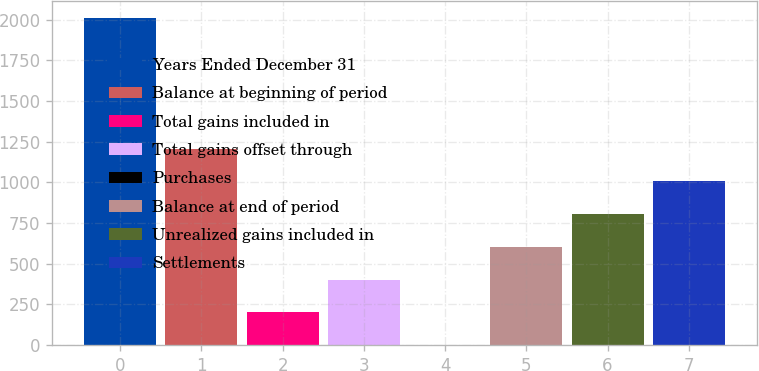<chart> <loc_0><loc_0><loc_500><loc_500><bar_chart><fcel>Years Ended December 31<fcel>Balance at beginning of period<fcel>Total gains included in<fcel>Total gains offset through<fcel>Purchases<fcel>Balance at end of period<fcel>Unrealized gains included in<fcel>Settlements<nl><fcel>2011<fcel>1207<fcel>202<fcel>403<fcel>1<fcel>604<fcel>805<fcel>1006<nl></chart> 